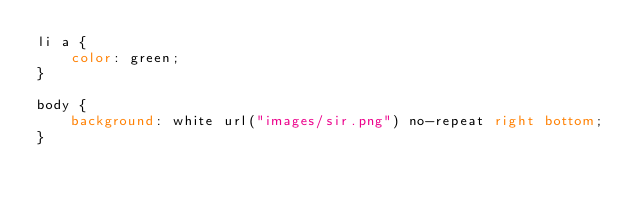<code> <loc_0><loc_0><loc_500><loc_500><_CSS_>li a {
    color: green;
}

body {
    background: white url("images/sir.png") no-repeat right bottom;
}</code> 